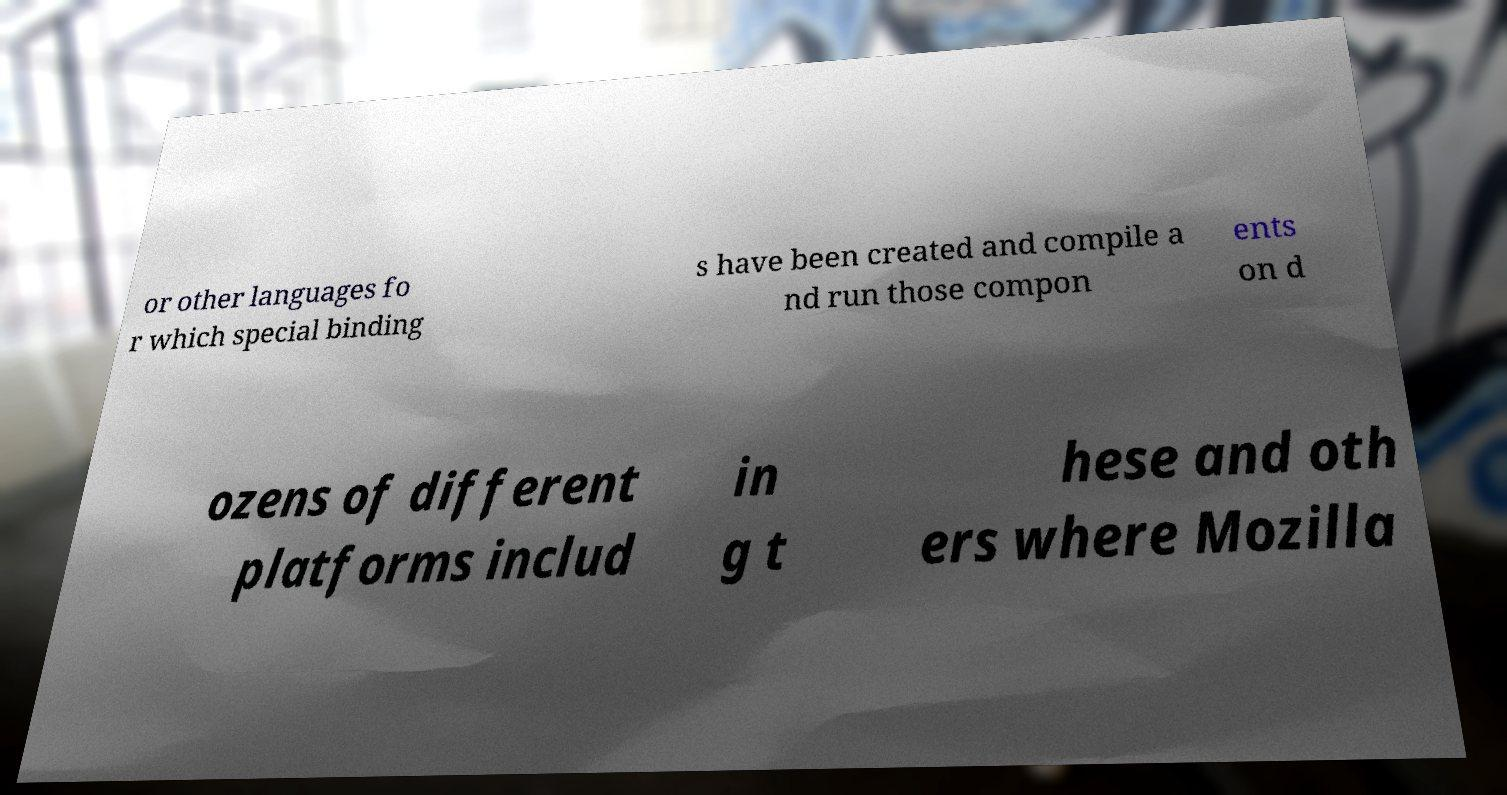Could you extract and type out the text from this image? or other languages fo r which special binding s have been created and compile a nd run those compon ents on d ozens of different platforms includ in g t hese and oth ers where Mozilla 